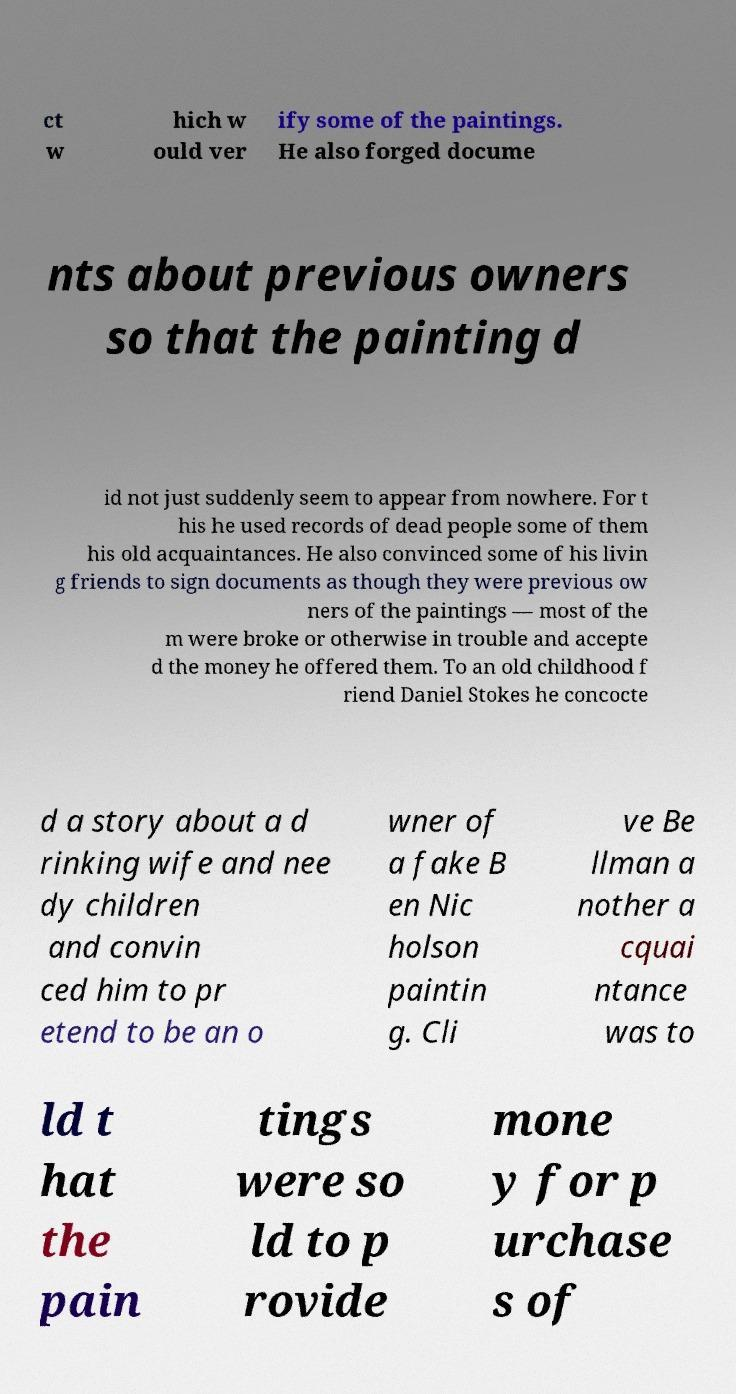I need the written content from this picture converted into text. Can you do that? ct w hich w ould ver ify some of the paintings. He also forged docume nts about previous owners so that the painting d id not just suddenly seem to appear from nowhere. For t his he used records of dead people some of them his old acquaintances. He also convinced some of his livin g friends to sign documents as though they were previous ow ners of the paintings — most of the m were broke or otherwise in trouble and accepte d the money he offered them. To an old childhood f riend Daniel Stokes he concocte d a story about a d rinking wife and nee dy children and convin ced him to pr etend to be an o wner of a fake B en Nic holson paintin g. Cli ve Be llman a nother a cquai ntance was to ld t hat the pain tings were so ld to p rovide mone y for p urchase s of 